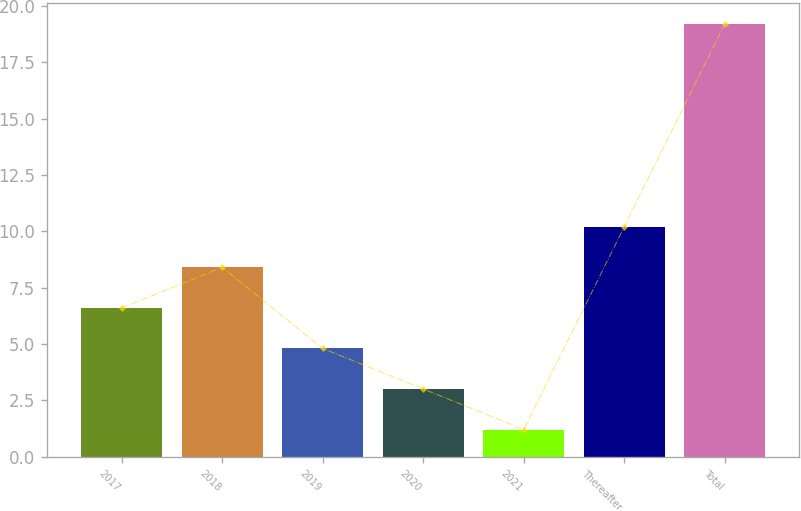Convert chart to OTSL. <chart><loc_0><loc_0><loc_500><loc_500><bar_chart><fcel>2017<fcel>2018<fcel>2019<fcel>2020<fcel>2021<fcel>Thereafter<fcel>Total<nl><fcel>6.6<fcel>8.4<fcel>4.8<fcel>3<fcel>1.2<fcel>10.2<fcel>19.2<nl></chart> 